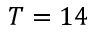<formula> <loc_0><loc_0><loc_500><loc_500>T = 1 4</formula> 